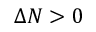Convert formula to latex. <formula><loc_0><loc_0><loc_500><loc_500>\Delta N > 0</formula> 